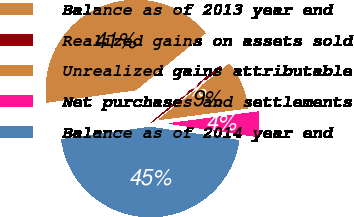<chart> <loc_0><loc_0><loc_500><loc_500><pie_chart><fcel>Balance as of 2013 year end<fcel>Realized gains on assets sold<fcel>Unrealized gains attributable<fcel>Net purchases and settlements<fcel>Balance as of 2014 year end<nl><fcel>41.28%<fcel>0.27%<fcel>8.58%<fcel>4.43%<fcel>45.43%<nl></chart> 